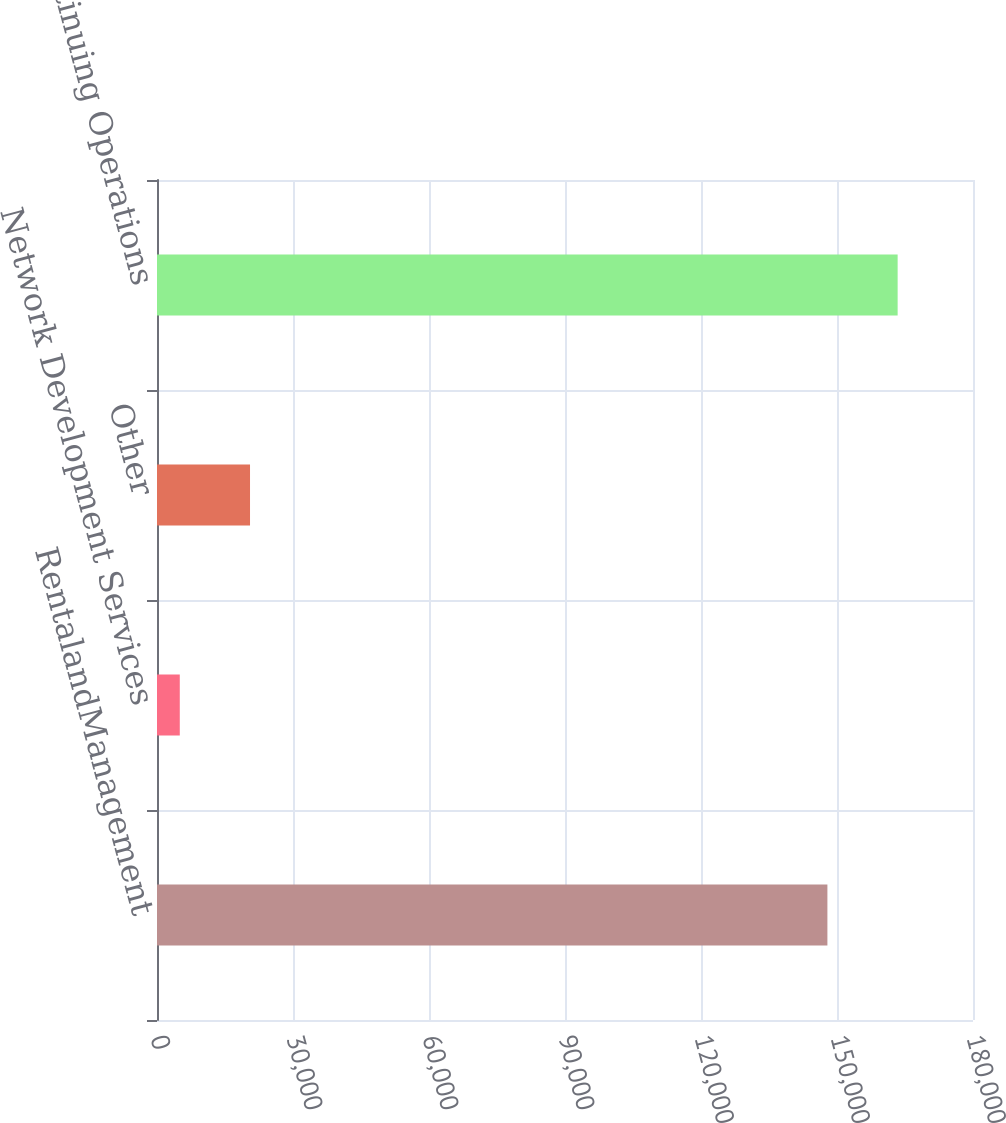Convert chart. <chart><loc_0><loc_0><loc_500><loc_500><bar_chart><fcel>RentalandManagement<fcel>Network Development Services<fcel>Other<fcel>Continuing Operations<nl><fcel>147883<fcel>5025<fcel>20519.4<fcel>163377<nl></chart> 